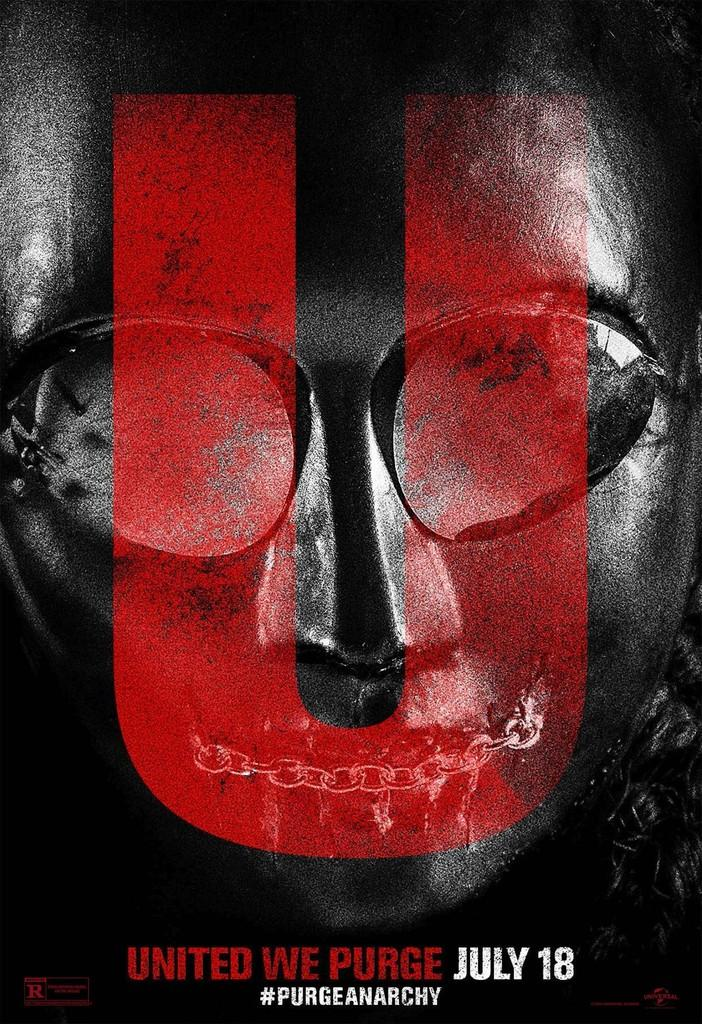What is the main subject of the image? The main subject of the image is a picture. What message is conveyed at the bottom of the picture? The text "UNITED WE PURGE JULY 18" is written at the bottom of the picture. What type of throat-soothing remedy is visible in the image? There is no throat-soothing remedy present in the image. Can you tell me how many volleyballs are in the image? There are no volleyballs present in the image. 